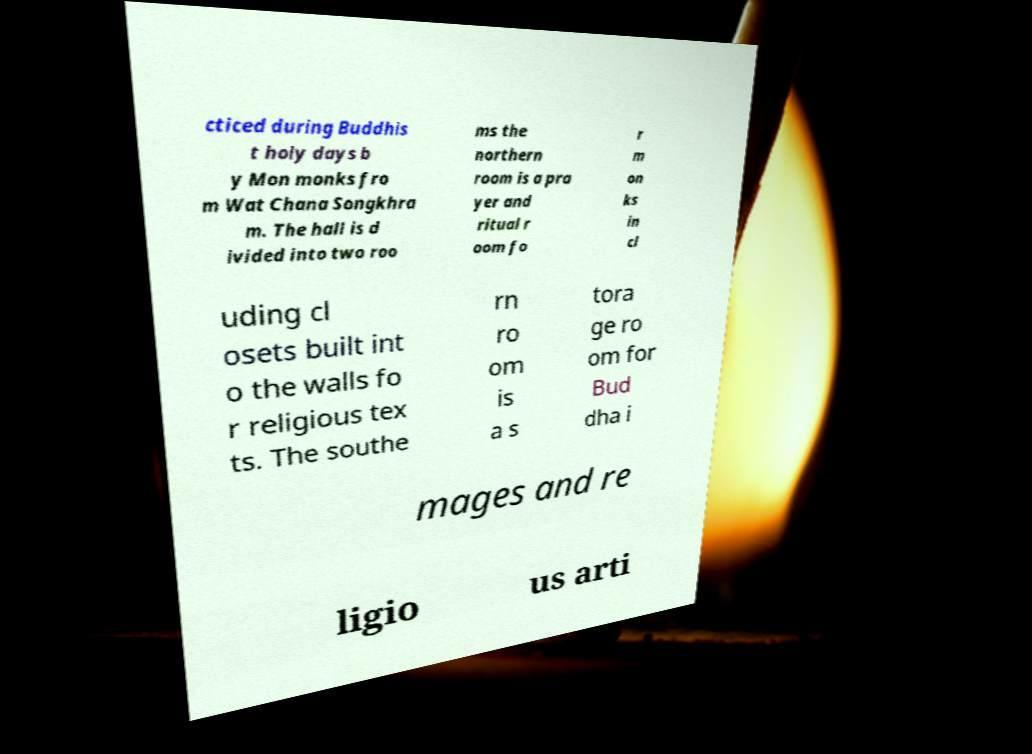What messages or text are displayed in this image? I need them in a readable, typed format. cticed during Buddhis t holy days b y Mon monks fro m Wat Chana Songkhra m. The hall is d ivided into two roo ms the northern room is a pra yer and ritual r oom fo r m on ks in cl uding cl osets built int o the walls fo r religious tex ts. The southe rn ro om is a s tora ge ro om for Bud dha i mages and re ligio us arti 